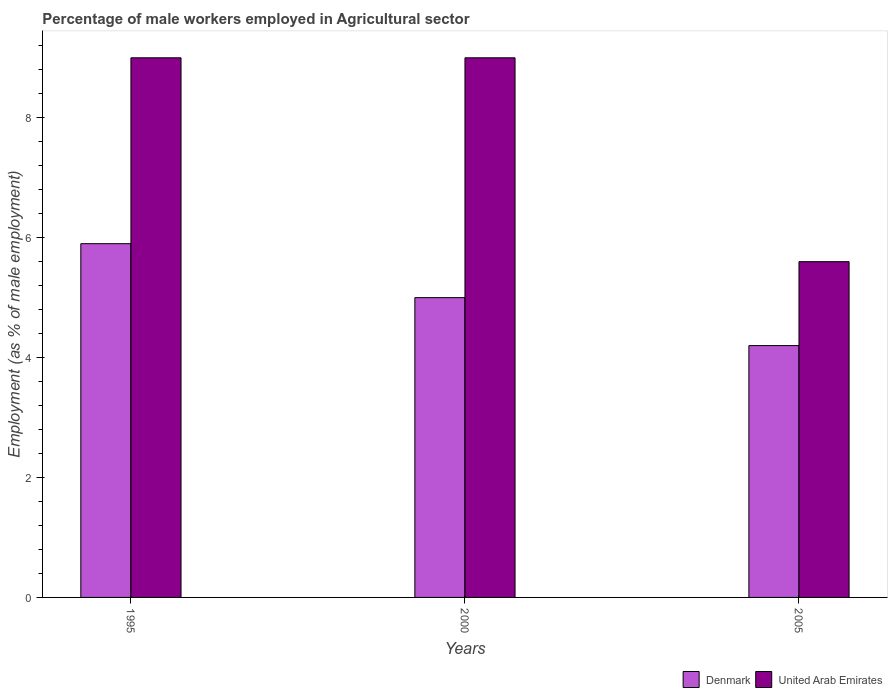Are the number of bars on each tick of the X-axis equal?
Provide a succinct answer. Yes. How many bars are there on the 2nd tick from the right?
Your answer should be very brief. 2. What is the label of the 1st group of bars from the left?
Your response must be concise. 1995. What is the percentage of male workers employed in Agricultural sector in United Arab Emirates in 2005?
Offer a terse response. 5.6. Across all years, what is the minimum percentage of male workers employed in Agricultural sector in United Arab Emirates?
Your response must be concise. 5.6. In which year was the percentage of male workers employed in Agricultural sector in United Arab Emirates minimum?
Make the answer very short. 2005. What is the total percentage of male workers employed in Agricultural sector in Denmark in the graph?
Your answer should be very brief. 15.1. What is the difference between the percentage of male workers employed in Agricultural sector in United Arab Emirates in 2000 and that in 2005?
Ensure brevity in your answer.  3.4. What is the difference between the percentage of male workers employed in Agricultural sector in Denmark in 2005 and the percentage of male workers employed in Agricultural sector in United Arab Emirates in 1995?
Offer a terse response. -4.8. What is the average percentage of male workers employed in Agricultural sector in Denmark per year?
Offer a terse response. 5.03. In the year 2000, what is the difference between the percentage of male workers employed in Agricultural sector in United Arab Emirates and percentage of male workers employed in Agricultural sector in Denmark?
Your answer should be compact. 4. In how many years, is the percentage of male workers employed in Agricultural sector in United Arab Emirates greater than 8.4 %?
Ensure brevity in your answer.  2. What is the ratio of the percentage of male workers employed in Agricultural sector in Denmark in 1995 to that in 2005?
Give a very brief answer. 1.4. Is the percentage of male workers employed in Agricultural sector in Denmark in 1995 less than that in 2000?
Offer a very short reply. No. Is the difference between the percentage of male workers employed in Agricultural sector in United Arab Emirates in 1995 and 2005 greater than the difference between the percentage of male workers employed in Agricultural sector in Denmark in 1995 and 2005?
Provide a short and direct response. Yes. What is the difference between the highest and the second highest percentage of male workers employed in Agricultural sector in Denmark?
Your answer should be very brief. 0.9. What is the difference between the highest and the lowest percentage of male workers employed in Agricultural sector in Denmark?
Provide a succinct answer. 1.7. What does the 1st bar from the left in 2000 represents?
Keep it short and to the point. Denmark. What does the 1st bar from the right in 2005 represents?
Your response must be concise. United Arab Emirates. How many bars are there?
Keep it short and to the point. 6. Are the values on the major ticks of Y-axis written in scientific E-notation?
Give a very brief answer. No. Does the graph contain grids?
Your answer should be very brief. No. Where does the legend appear in the graph?
Ensure brevity in your answer.  Bottom right. What is the title of the graph?
Your answer should be very brief. Percentage of male workers employed in Agricultural sector. Does "Estonia" appear as one of the legend labels in the graph?
Ensure brevity in your answer.  No. What is the label or title of the X-axis?
Give a very brief answer. Years. What is the label or title of the Y-axis?
Keep it short and to the point. Employment (as % of male employment). What is the Employment (as % of male employment) of Denmark in 1995?
Give a very brief answer. 5.9. What is the Employment (as % of male employment) in United Arab Emirates in 1995?
Offer a very short reply. 9. What is the Employment (as % of male employment) in Denmark in 2000?
Offer a very short reply. 5. What is the Employment (as % of male employment) in United Arab Emirates in 2000?
Make the answer very short. 9. What is the Employment (as % of male employment) of Denmark in 2005?
Give a very brief answer. 4.2. What is the Employment (as % of male employment) of United Arab Emirates in 2005?
Give a very brief answer. 5.6. Across all years, what is the maximum Employment (as % of male employment) of Denmark?
Offer a very short reply. 5.9. Across all years, what is the maximum Employment (as % of male employment) of United Arab Emirates?
Make the answer very short. 9. Across all years, what is the minimum Employment (as % of male employment) of Denmark?
Offer a very short reply. 4.2. Across all years, what is the minimum Employment (as % of male employment) of United Arab Emirates?
Give a very brief answer. 5.6. What is the total Employment (as % of male employment) of Denmark in the graph?
Offer a very short reply. 15.1. What is the total Employment (as % of male employment) of United Arab Emirates in the graph?
Ensure brevity in your answer.  23.6. What is the difference between the Employment (as % of male employment) of Denmark in 1995 and that in 2000?
Ensure brevity in your answer.  0.9. What is the difference between the Employment (as % of male employment) of United Arab Emirates in 1995 and that in 2005?
Ensure brevity in your answer.  3.4. What is the difference between the Employment (as % of male employment) of United Arab Emirates in 2000 and that in 2005?
Provide a succinct answer. 3.4. What is the difference between the Employment (as % of male employment) of Denmark in 2000 and the Employment (as % of male employment) of United Arab Emirates in 2005?
Your answer should be compact. -0.6. What is the average Employment (as % of male employment) of Denmark per year?
Keep it short and to the point. 5.03. What is the average Employment (as % of male employment) in United Arab Emirates per year?
Provide a succinct answer. 7.87. In the year 2000, what is the difference between the Employment (as % of male employment) in Denmark and Employment (as % of male employment) in United Arab Emirates?
Keep it short and to the point. -4. In the year 2005, what is the difference between the Employment (as % of male employment) in Denmark and Employment (as % of male employment) in United Arab Emirates?
Your answer should be compact. -1.4. What is the ratio of the Employment (as % of male employment) in Denmark in 1995 to that in 2000?
Your answer should be very brief. 1.18. What is the ratio of the Employment (as % of male employment) in Denmark in 1995 to that in 2005?
Your response must be concise. 1.4. What is the ratio of the Employment (as % of male employment) of United Arab Emirates in 1995 to that in 2005?
Keep it short and to the point. 1.61. What is the ratio of the Employment (as % of male employment) of Denmark in 2000 to that in 2005?
Your answer should be very brief. 1.19. What is the ratio of the Employment (as % of male employment) in United Arab Emirates in 2000 to that in 2005?
Provide a succinct answer. 1.61. What is the difference between the highest and the second highest Employment (as % of male employment) of Denmark?
Your answer should be very brief. 0.9. What is the difference between the highest and the second highest Employment (as % of male employment) in United Arab Emirates?
Ensure brevity in your answer.  0. What is the difference between the highest and the lowest Employment (as % of male employment) in Denmark?
Offer a terse response. 1.7. What is the difference between the highest and the lowest Employment (as % of male employment) in United Arab Emirates?
Ensure brevity in your answer.  3.4. 